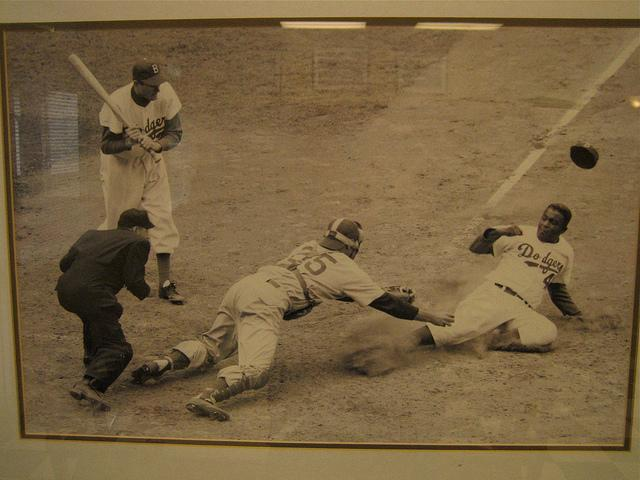What person is sliding?

Choices:
A) jackie chan
B) jackie brown
C) jackie kennedy
D) jackie robinson jackie robinson 